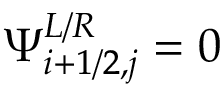<formula> <loc_0><loc_0><loc_500><loc_500>\Psi _ { i + 1 / 2 , j } ^ { L / R } = 0</formula> 